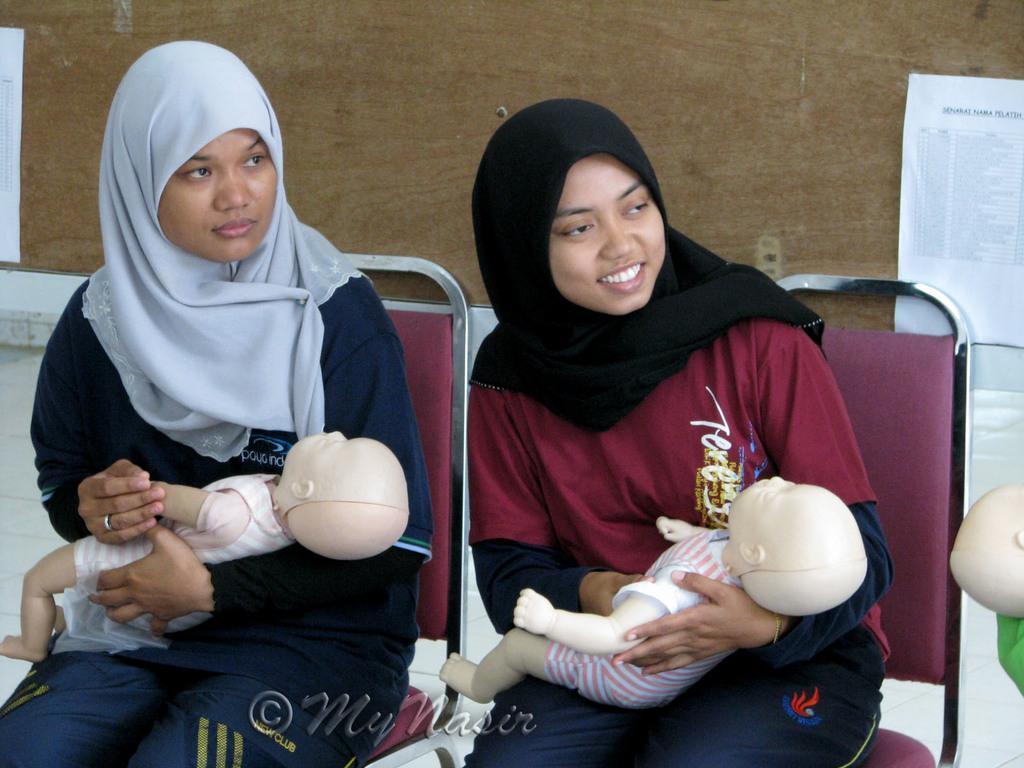Please provide a concise description of this image. In this image we can see two ladies sitting on chairs. They are holding toys. In the back there is a wall with papers. On the papers there is text. 